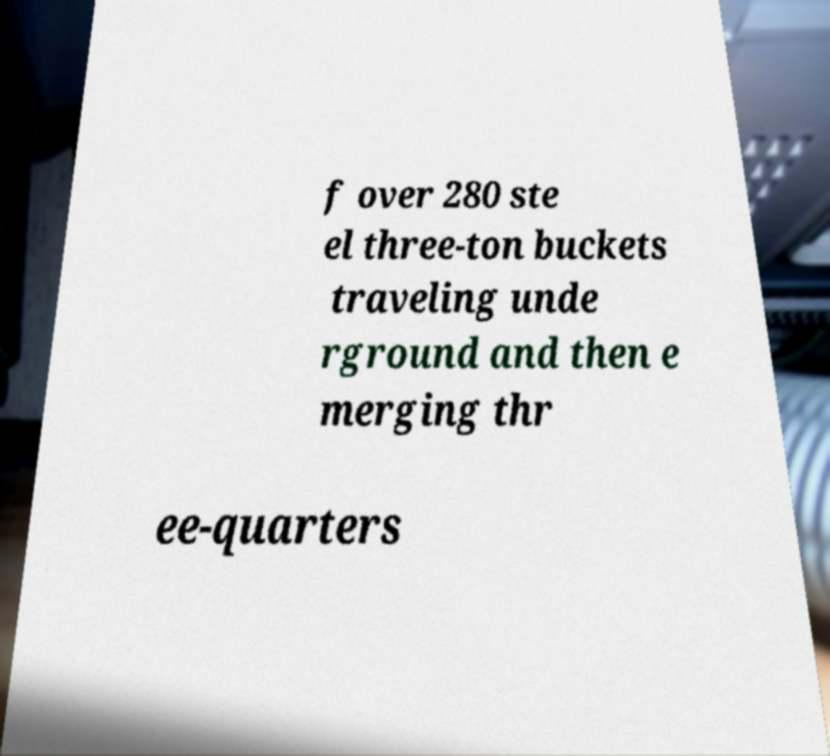Can you read and provide the text displayed in the image?This photo seems to have some interesting text. Can you extract and type it out for me? f over 280 ste el three-ton buckets traveling unde rground and then e merging thr ee-quarters 